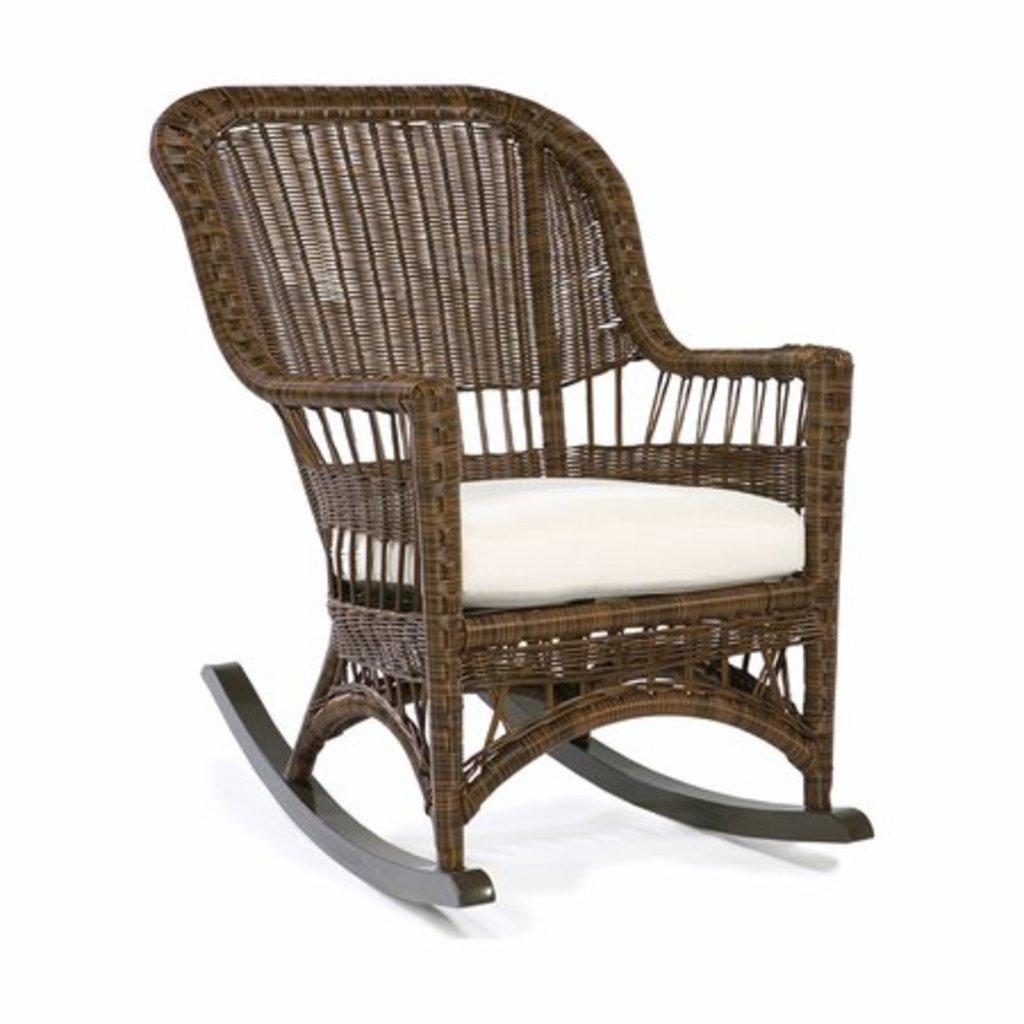What type of chair is in the image? There is a wooden chair in the image. What is on the wooden chair? The wooden chair has a white cushion on it. What is the effect of the metal on the wooden chair in the image? There is no metal mentioned in the image, so it is not possible to determine any effect on the wooden chair. 